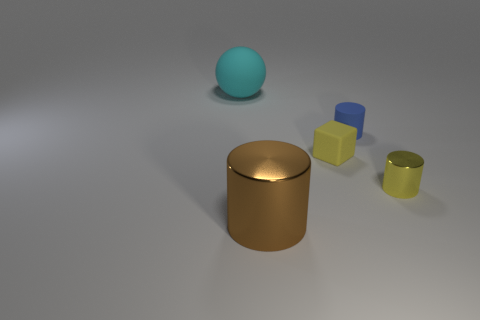Subtract all tiny cylinders. How many cylinders are left? 1 Add 2 big cyan spheres. How many objects exist? 7 Subtract all yellow cylinders. How many cylinders are left? 2 Subtract all cylinders. How many objects are left? 2 Subtract 2 cylinders. How many cylinders are left? 1 Add 2 small yellow blocks. How many small yellow blocks are left? 3 Add 5 spheres. How many spheres exist? 6 Subtract 0 gray cylinders. How many objects are left? 5 Subtract all blue spheres. Subtract all red blocks. How many spheres are left? 1 Subtract all cyan balls. Subtract all blue cylinders. How many objects are left? 3 